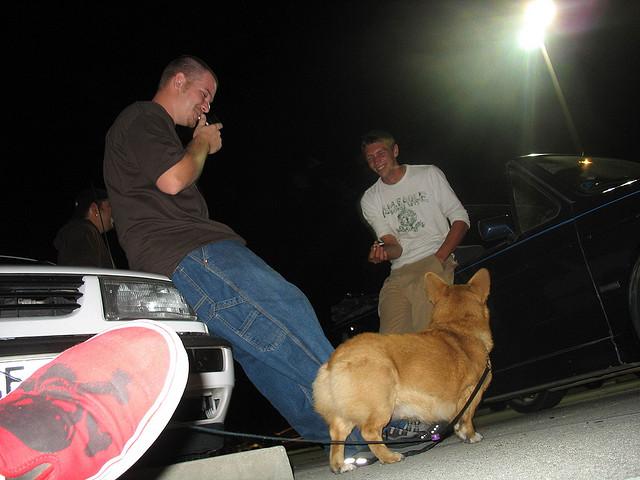Is this picture taken in the morning?
Give a very brief answer. No. Who is wearing glasses?
Be succinct. No one. What animal is on the ground?
Short answer required. Dog. Does the shoe intrude into the picture?
Keep it brief. Yes. 